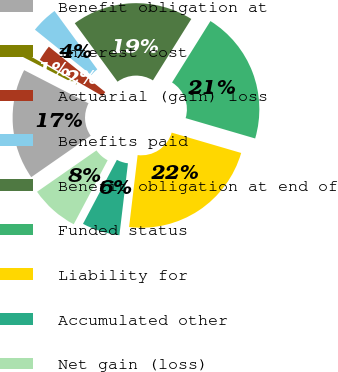Convert chart to OTSL. <chart><loc_0><loc_0><loc_500><loc_500><pie_chart><fcel>Benefit obligation at<fcel>Interest cost<fcel>Actuarial (gain) loss<fcel>Benefits paid<fcel>Benefit obligation at end of<fcel>Funded status<fcel>Liability for<fcel>Accumulated other<fcel>Net gain (loss)<nl><fcel>17.24%<fcel>0.76%<fcel>2.46%<fcel>4.16%<fcel>18.94%<fcel>20.64%<fcel>22.35%<fcel>5.87%<fcel>7.57%<nl></chart> 